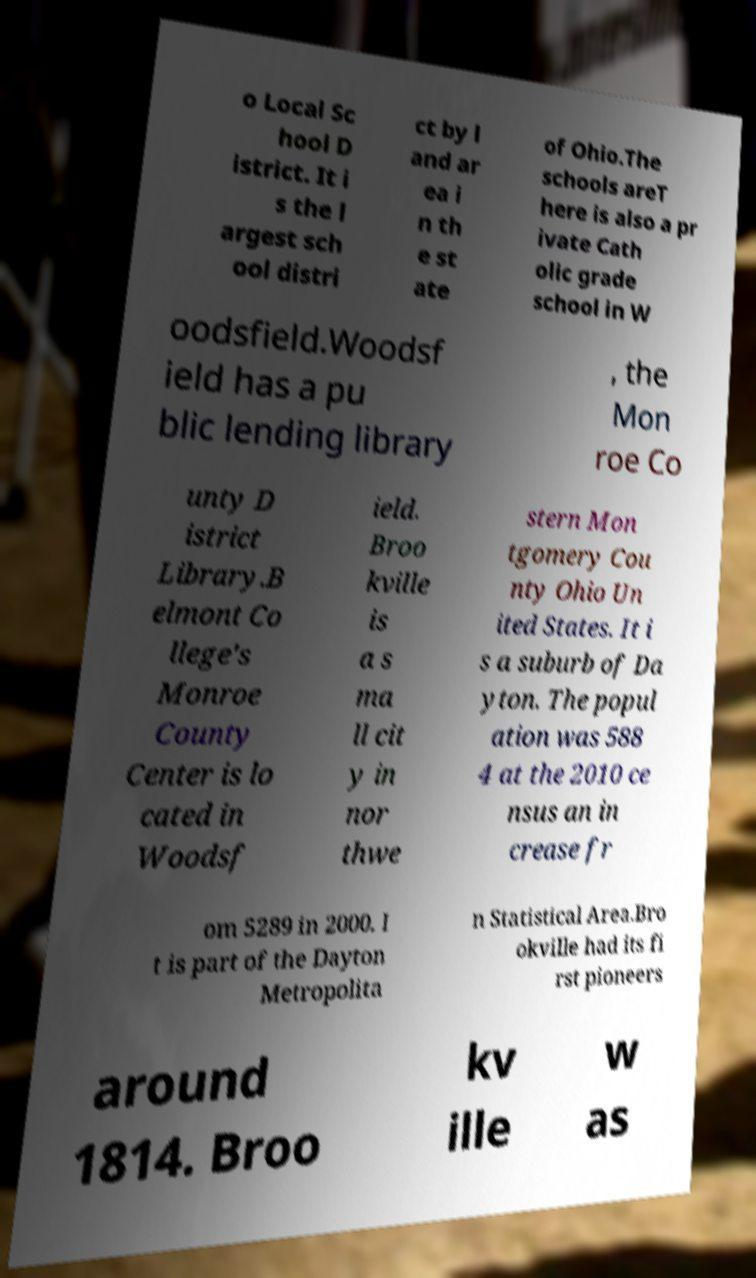For documentation purposes, I need the text within this image transcribed. Could you provide that? o Local Sc hool D istrict. It i s the l argest sch ool distri ct by l and ar ea i n th e st ate of Ohio.The schools areT here is also a pr ivate Cath olic grade school in W oodsfield.Woodsf ield has a pu blic lending library , the Mon roe Co unty D istrict Library.B elmont Co llege's Monroe County Center is lo cated in Woodsf ield. Broo kville is a s ma ll cit y in nor thwe stern Mon tgomery Cou nty Ohio Un ited States. It i s a suburb of Da yton. The popul ation was 588 4 at the 2010 ce nsus an in crease fr om 5289 in 2000. I t is part of the Dayton Metropolita n Statistical Area.Bro okville had its fi rst pioneers around 1814. Broo kv ille w as 